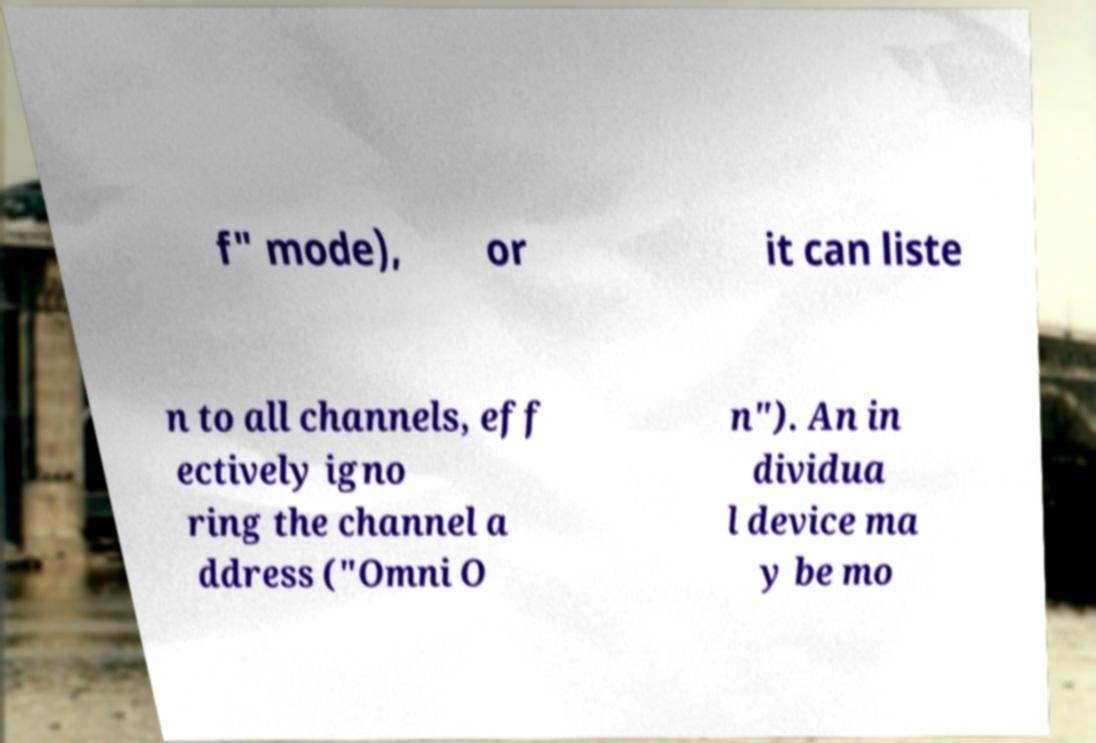Could you extract and type out the text from this image? f" mode), or it can liste n to all channels, eff ectively igno ring the channel a ddress ("Omni O n"). An in dividua l device ma y be mo 